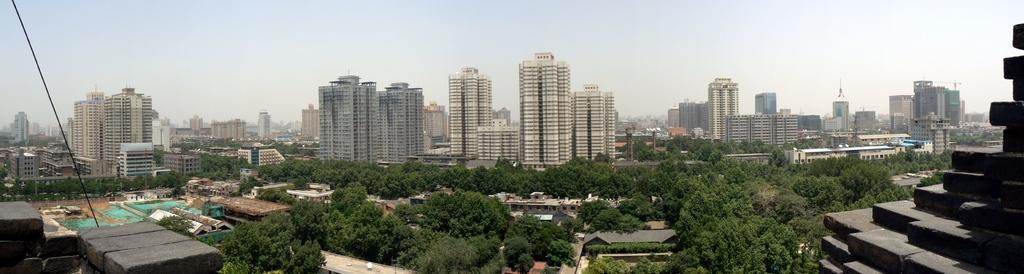What type of vegetation can be seen in the image? There are trees in the image. What type of structures are present in the image? There are buildings and skyscrapers in the image. What is visible in the background of the image? The sky is visible in the image. Can you tell me how many sheep are in the flock depicted in the image? There is no flock of sheep present in the image; it features trees, buildings, and skyscrapers. What type of shock can be seen affecting the market in the image? There is no market or shock depicted in the image; it only shows trees, buildings, and skyscrapers. 